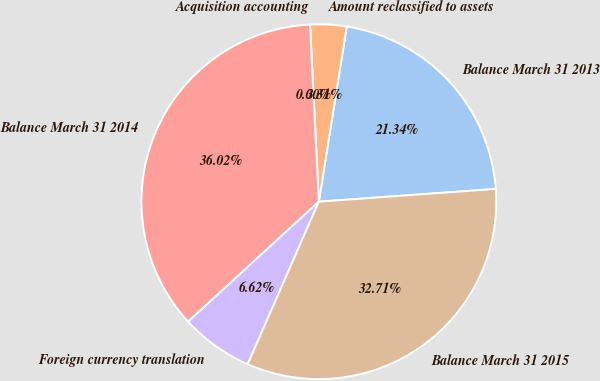<chart> <loc_0><loc_0><loc_500><loc_500><pie_chart><fcel>Balance March 31 2013<fcel>Amount reclassified to assets<fcel>Acquisition accounting<fcel>Balance March 31 2014<fcel>Foreign currency translation<fcel>Balance March 31 2015<nl><fcel>21.34%<fcel>3.31%<fcel>0.0%<fcel>36.02%<fcel>6.62%<fcel>32.71%<nl></chart> 